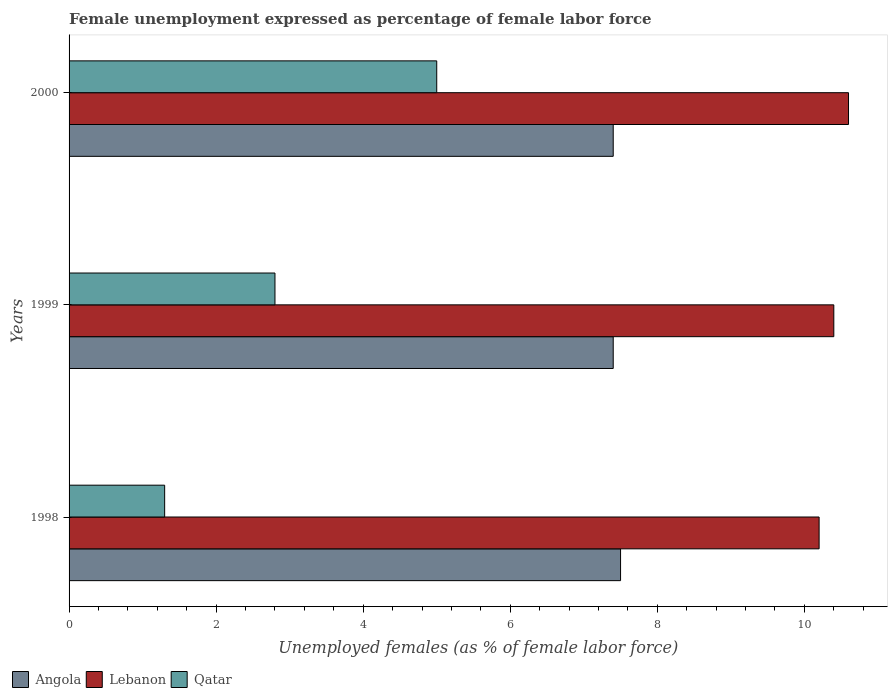How many different coloured bars are there?
Provide a succinct answer. 3. How many groups of bars are there?
Offer a very short reply. 3. Are the number of bars on each tick of the Y-axis equal?
Give a very brief answer. Yes. How many bars are there on the 3rd tick from the top?
Your answer should be compact. 3. In how many cases, is the number of bars for a given year not equal to the number of legend labels?
Make the answer very short. 0. What is the unemployment in females in in Angola in 2000?
Ensure brevity in your answer.  7.4. Across all years, what is the maximum unemployment in females in in Qatar?
Ensure brevity in your answer.  5. Across all years, what is the minimum unemployment in females in in Qatar?
Your answer should be compact. 1.3. What is the total unemployment in females in in Lebanon in the graph?
Provide a short and direct response. 31.2. What is the difference between the unemployment in females in in Angola in 1998 and that in 2000?
Keep it short and to the point. 0.1. What is the difference between the unemployment in females in in Lebanon in 1998 and the unemployment in females in in Angola in 1999?
Your answer should be very brief. 2.8. What is the average unemployment in females in in Angola per year?
Provide a succinct answer. 7.43. In the year 1999, what is the difference between the unemployment in females in in Lebanon and unemployment in females in in Qatar?
Provide a short and direct response. 7.6. What is the ratio of the unemployment in females in in Angola in 1998 to that in 2000?
Provide a succinct answer. 1.01. What is the difference between the highest and the second highest unemployment in females in in Qatar?
Make the answer very short. 2.2. What is the difference between the highest and the lowest unemployment in females in in Qatar?
Your response must be concise. 3.7. Is the sum of the unemployment in females in in Angola in 1998 and 1999 greater than the maximum unemployment in females in in Lebanon across all years?
Provide a short and direct response. Yes. What does the 3rd bar from the top in 1999 represents?
Offer a terse response. Angola. What does the 1st bar from the bottom in 2000 represents?
Ensure brevity in your answer.  Angola. Is it the case that in every year, the sum of the unemployment in females in in Qatar and unemployment in females in in Lebanon is greater than the unemployment in females in in Angola?
Keep it short and to the point. Yes. How many bars are there?
Make the answer very short. 9. Are all the bars in the graph horizontal?
Make the answer very short. Yes. What is the difference between two consecutive major ticks on the X-axis?
Ensure brevity in your answer.  2. Are the values on the major ticks of X-axis written in scientific E-notation?
Give a very brief answer. No. Where does the legend appear in the graph?
Give a very brief answer. Bottom left. How are the legend labels stacked?
Your answer should be compact. Horizontal. What is the title of the graph?
Provide a succinct answer. Female unemployment expressed as percentage of female labor force. Does "Namibia" appear as one of the legend labels in the graph?
Ensure brevity in your answer.  No. What is the label or title of the X-axis?
Make the answer very short. Unemployed females (as % of female labor force). What is the label or title of the Y-axis?
Ensure brevity in your answer.  Years. What is the Unemployed females (as % of female labor force) of Lebanon in 1998?
Provide a short and direct response. 10.2. What is the Unemployed females (as % of female labor force) in Qatar in 1998?
Offer a very short reply. 1.3. What is the Unemployed females (as % of female labor force) in Angola in 1999?
Your response must be concise. 7.4. What is the Unemployed females (as % of female labor force) of Lebanon in 1999?
Your answer should be very brief. 10.4. What is the Unemployed females (as % of female labor force) of Qatar in 1999?
Provide a succinct answer. 2.8. What is the Unemployed females (as % of female labor force) of Angola in 2000?
Your answer should be compact. 7.4. What is the Unemployed females (as % of female labor force) of Lebanon in 2000?
Provide a short and direct response. 10.6. Across all years, what is the maximum Unemployed females (as % of female labor force) in Angola?
Your response must be concise. 7.5. Across all years, what is the maximum Unemployed females (as % of female labor force) in Lebanon?
Your answer should be compact. 10.6. Across all years, what is the maximum Unemployed females (as % of female labor force) of Qatar?
Ensure brevity in your answer.  5. Across all years, what is the minimum Unemployed females (as % of female labor force) of Angola?
Provide a succinct answer. 7.4. Across all years, what is the minimum Unemployed females (as % of female labor force) in Lebanon?
Your answer should be very brief. 10.2. Across all years, what is the minimum Unemployed females (as % of female labor force) in Qatar?
Your answer should be compact. 1.3. What is the total Unemployed females (as % of female labor force) in Angola in the graph?
Your response must be concise. 22.3. What is the total Unemployed females (as % of female labor force) of Lebanon in the graph?
Your answer should be very brief. 31.2. What is the total Unemployed females (as % of female labor force) of Qatar in the graph?
Make the answer very short. 9.1. What is the difference between the Unemployed females (as % of female labor force) in Lebanon in 1998 and that in 1999?
Your response must be concise. -0.2. What is the difference between the Unemployed females (as % of female labor force) of Qatar in 1998 and that in 1999?
Provide a succinct answer. -1.5. What is the difference between the Unemployed females (as % of female labor force) in Lebanon in 1998 and that in 2000?
Your answer should be compact. -0.4. What is the difference between the Unemployed females (as % of female labor force) of Angola in 1998 and the Unemployed females (as % of female labor force) of Lebanon in 1999?
Ensure brevity in your answer.  -2.9. What is the difference between the Unemployed females (as % of female labor force) of Angola in 1998 and the Unemployed females (as % of female labor force) of Qatar in 1999?
Your answer should be compact. 4.7. What is the difference between the Unemployed females (as % of female labor force) of Angola in 1999 and the Unemployed females (as % of female labor force) of Qatar in 2000?
Offer a terse response. 2.4. What is the average Unemployed females (as % of female labor force) in Angola per year?
Your answer should be compact. 7.43. What is the average Unemployed females (as % of female labor force) in Lebanon per year?
Your answer should be compact. 10.4. What is the average Unemployed females (as % of female labor force) of Qatar per year?
Make the answer very short. 3.03. In the year 1998, what is the difference between the Unemployed females (as % of female labor force) in Angola and Unemployed females (as % of female labor force) in Lebanon?
Give a very brief answer. -2.7. In the year 1998, what is the difference between the Unemployed females (as % of female labor force) in Angola and Unemployed females (as % of female labor force) in Qatar?
Your answer should be compact. 6.2. In the year 1998, what is the difference between the Unemployed females (as % of female labor force) in Lebanon and Unemployed females (as % of female labor force) in Qatar?
Provide a short and direct response. 8.9. In the year 1999, what is the difference between the Unemployed females (as % of female labor force) of Angola and Unemployed females (as % of female labor force) of Lebanon?
Your answer should be compact. -3. In the year 1999, what is the difference between the Unemployed females (as % of female labor force) of Angola and Unemployed females (as % of female labor force) of Qatar?
Provide a short and direct response. 4.6. In the year 2000, what is the difference between the Unemployed females (as % of female labor force) in Angola and Unemployed females (as % of female labor force) in Lebanon?
Your answer should be compact. -3.2. What is the ratio of the Unemployed females (as % of female labor force) in Angola in 1998 to that in 1999?
Make the answer very short. 1.01. What is the ratio of the Unemployed females (as % of female labor force) of Lebanon in 1998 to that in 1999?
Offer a terse response. 0.98. What is the ratio of the Unemployed females (as % of female labor force) of Qatar in 1998 to that in 1999?
Your response must be concise. 0.46. What is the ratio of the Unemployed females (as % of female labor force) of Angola in 1998 to that in 2000?
Your response must be concise. 1.01. What is the ratio of the Unemployed females (as % of female labor force) of Lebanon in 1998 to that in 2000?
Your answer should be very brief. 0.96. What is the ratio of the Unemployed females (as % of female labor force) of Qatar in 1998 to that in 2000?
Your response must be concise. 0.26. What is the ratio of the Unemployed females (as % of female labor force) in Lebanon in 1999 to that in 2000?
Offer a very short reply. 0.98. What is the ratio of the Unemployed females (as % of female labor force) in Qatar in 1999 to that in 2000?
Your answer should be compact. 0.56. What is the difference between the highest and the second highest Unemployed females (as % of female labor force) of Angola?
Give a very brief answer. 0.1. What is the difference between the highest and the second highest Unemployed females (as % of female labor force) of Qatar?
Keep it short and to the point. 2.2. What is the difference between the highest and the lowest Unemployed females (as % of female labor force) of Angola?
Your answer should be compact. 0.1. What is the difference between the highest and the lowest Unemployed females (as % of female labor force) in Lebanon?
Give a very brief answer. 0.4. 